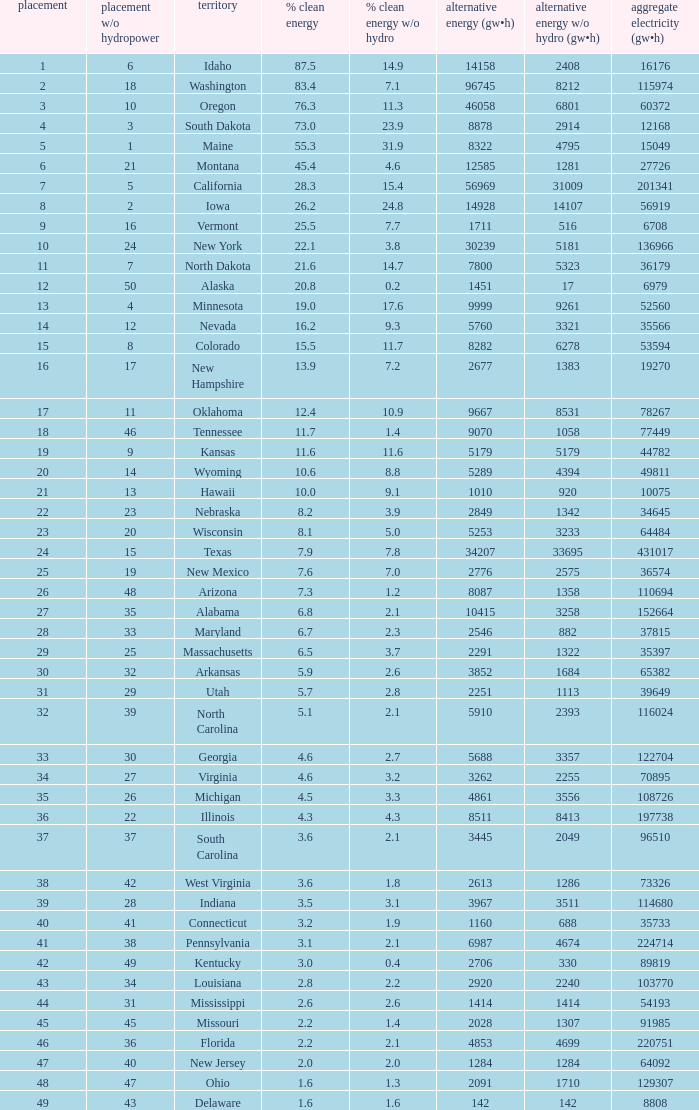What is the amount of renewable electricity without hydrogen power when the percentage of renewable energy is 83.4? 8212.0. 